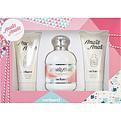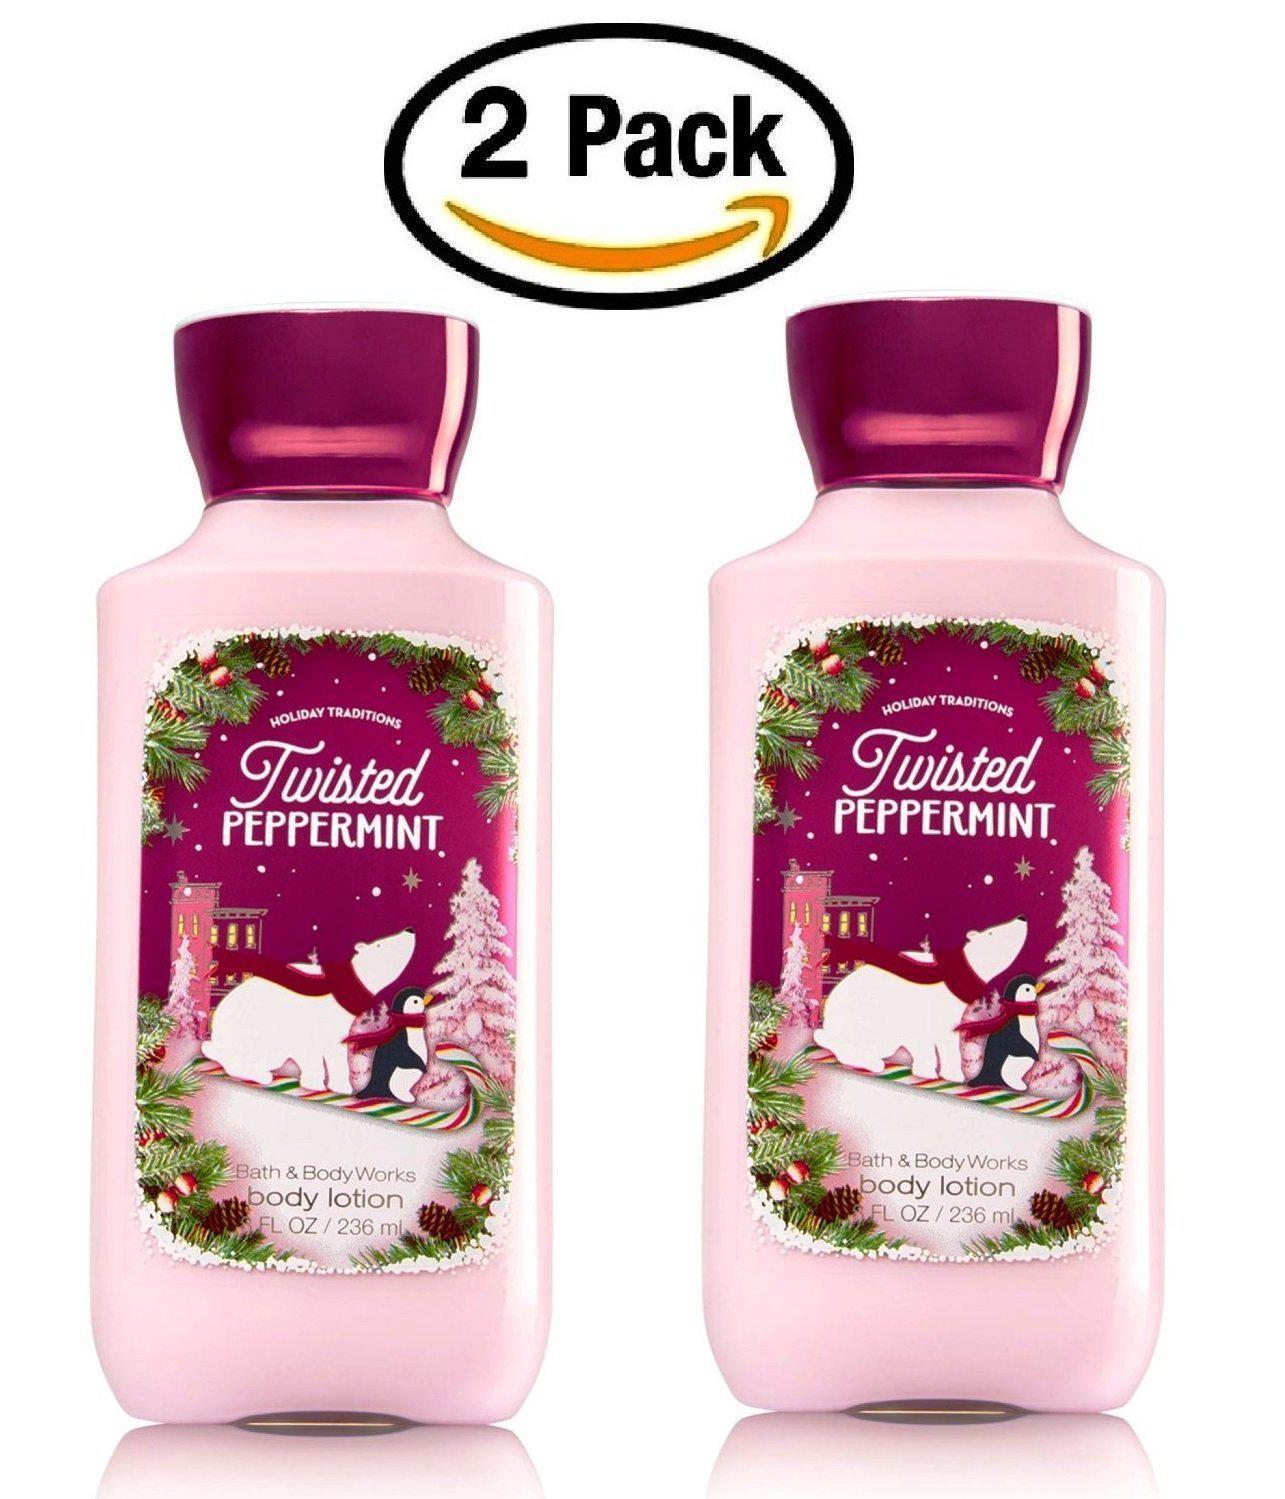The first image is the image on the left, the second image is the image on the right. For the images displayed, is the sentence "One of the images shows four or more products." factually correct? Answer yes or no. No. The first image is the image on the left, the second image is the image on the right. Examine the images to the left and right. Is the description "An image with no more than four items includes exactly one product that stands on its cap." accurate? Answer yes or no. No. 